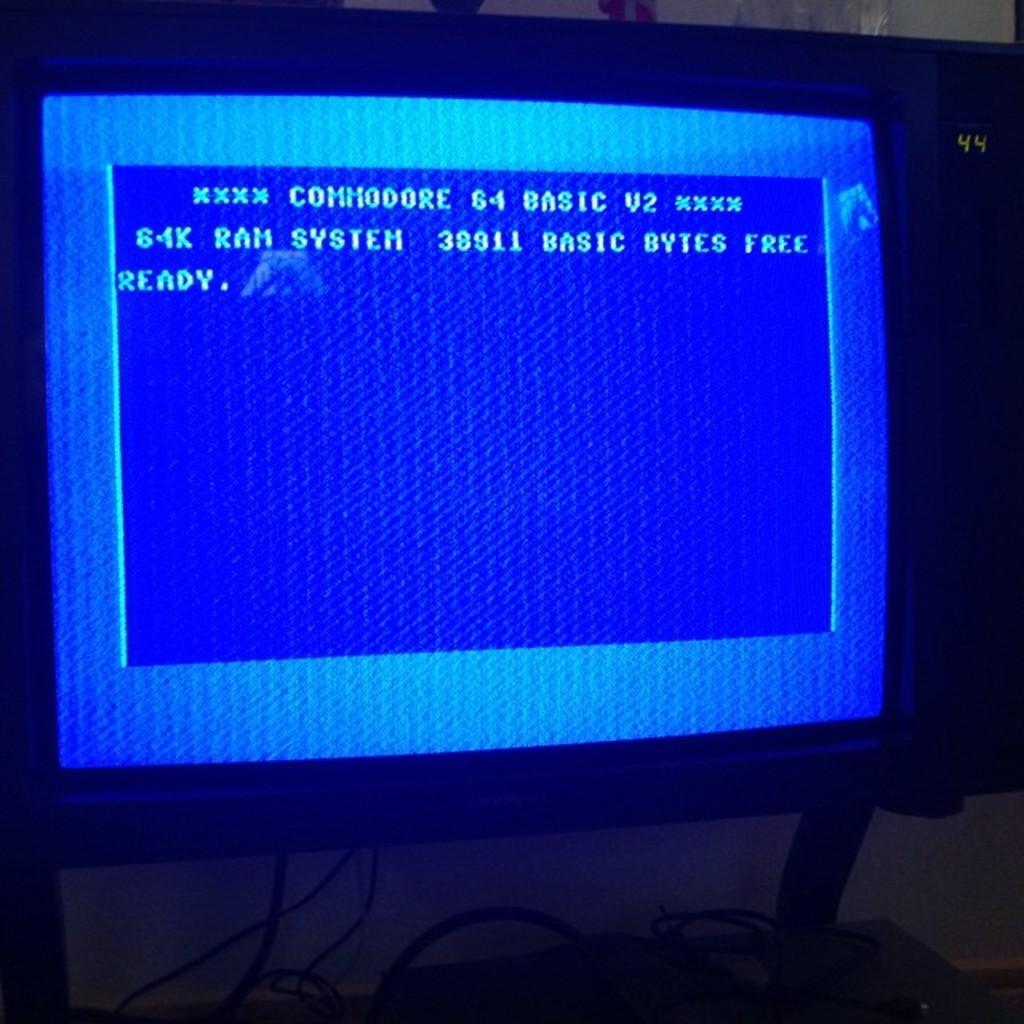What is the name of the computer operating system?
Make the answer very short. Commodore 64 basic v2. How much ram does this computer have?
Make the answer very short. 64k. 